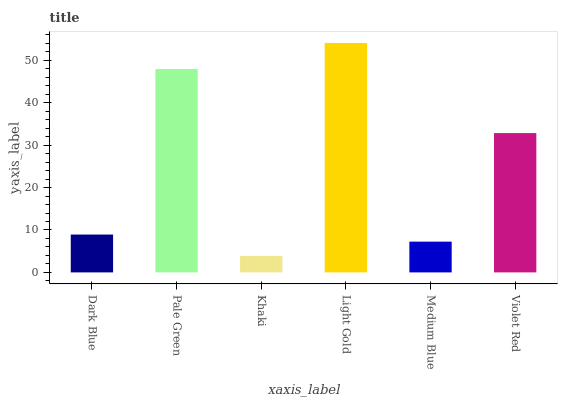Is Khaki the minimum?
Answer yes or no. Yes. Is Light Gold the maximum?
Answer yes or no. Yes. Is Pale Green the minimum?
Answer yes or no. No. Is Pale Green the maximum?
Answer yes or no. No. Is Pale Green greater than Dark Blue?
Answer yes or no. Yes. Is Dark Blue less than Pale Green?
Answer yes or no. Yes. Is Dark Blue greater than Pale Green?
Answer yes or no. No. Is Pale Green less than Dark Blue?
Answer yes or no. No. Is Violet Red the high median?
Answer yes or no. Yes. Is Dark Blue the low median?
Answer yes or no. Yes. Is Medium Blue the high median?
Answer yes or no. No. Is Khaki the low median?
Answer yes or no. No. 